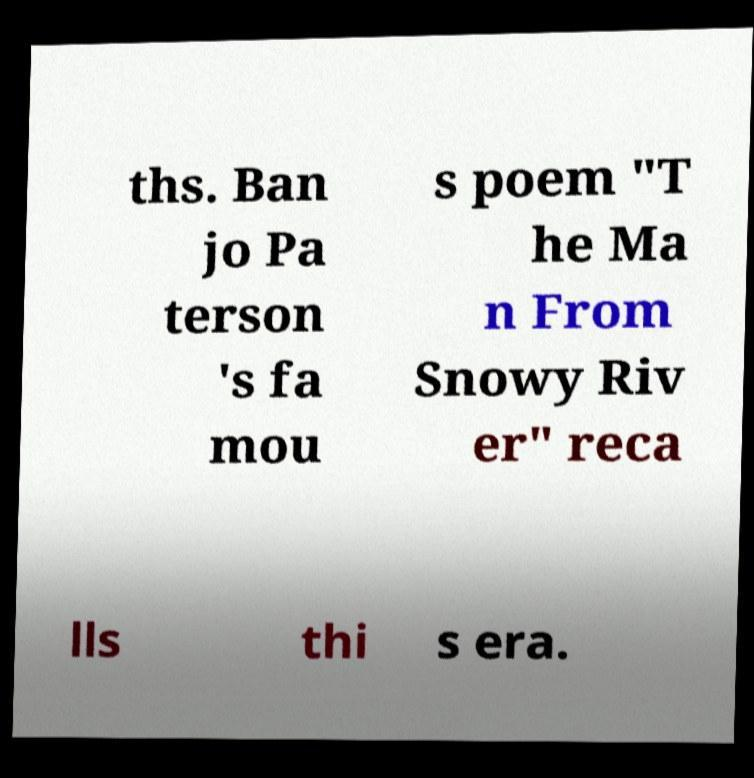Could you extract and type out the text from this image? ths. Ban jo Pa terson 's fa mou s poem "T he Ma n From Snowy Riv er" reca lls thi s era. 